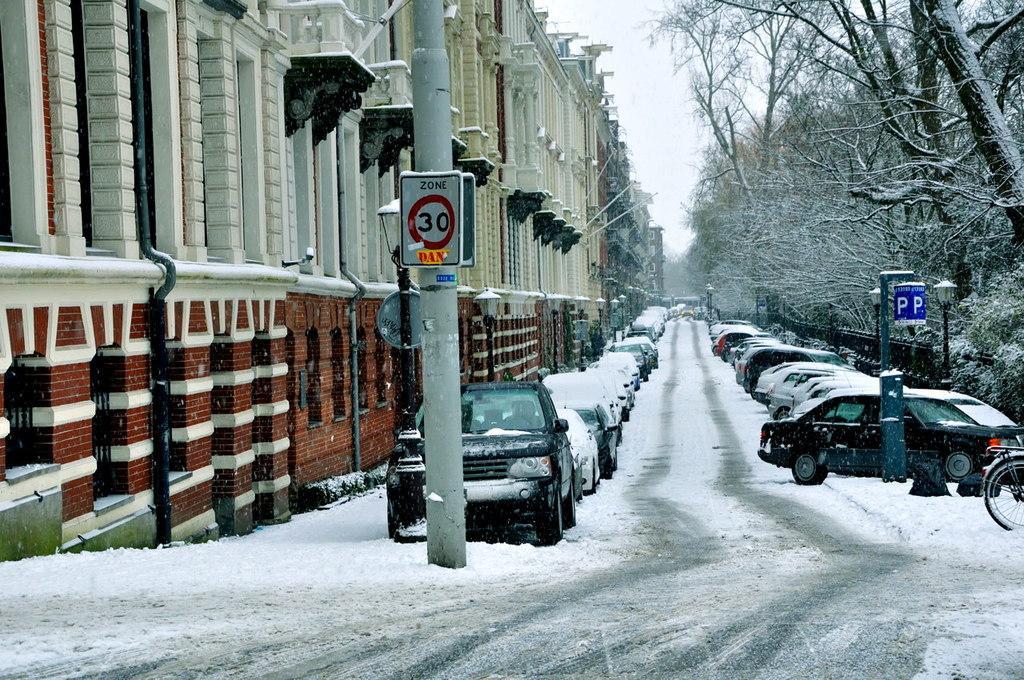How would you summarize this image in a sentence or two? In the center of the image there are cars on the road. On the left side of the image there are buildings. At the bottom of the image there is snow on the surface. On the right side of the image there are trees. There are poles. There are street lights. In the background of the image there is sky. 